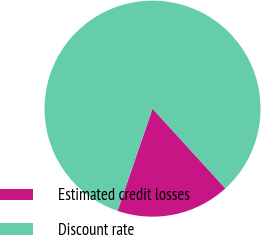<chart> <loc_0><loc_0><loc_500><loc_500><pie_chart><fcel>Estimated credit losses<fcel>Discount rate<nl><fcel>17.03%<fcel>82.97%<nl></chart> 